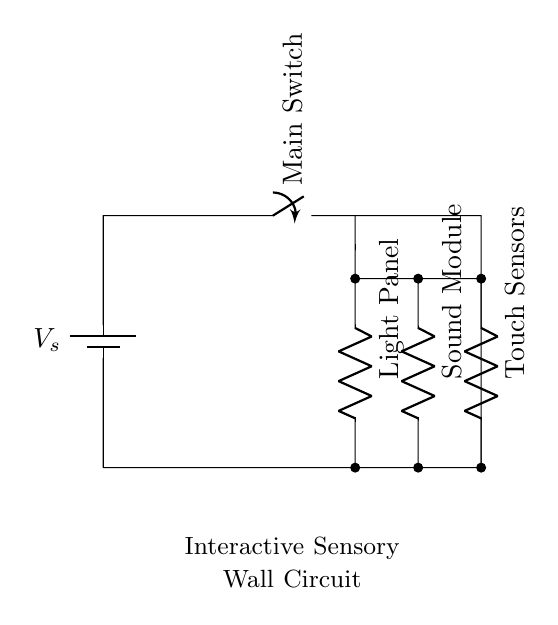What is the main power source of the circuit? The circuit is powered by a battery, indicated by the component labeled as voltage source.
Answer: battery What components are connected in parallel? The light panel, sound module, and touch sensors are all connected in parallel, as they connect to the same nodes of the battery and share the same voltage.
Answer: light panel, sound module, touch sensors How many resistive components are present? There are three resistive components in the circuit, which are the light panel, sound module, and touch sensors, all identified by 'R' in the diagram.
Answer: three What would happen if the main switch is closed? Closing the main switch would complete the circuit, allowing current to flow to all parallel components simultaneously, thus activating all sensory outputs.
Answer: all outputs activate What type of switch is used in the circuit? The circuit uses a main switch, an on/off type that controls the flow of current in the circuit.
Answer: main switch Explain how the voltage is distributed in this parallel circuit. In a parallel circuit, the voltage across all components is the same as the source voltage; therefore, each of the components (light panel, sound module, touch sensors) receives the same voltage supplied by the battery, regardless of their individual resistances.
Answer: same as source voltage 